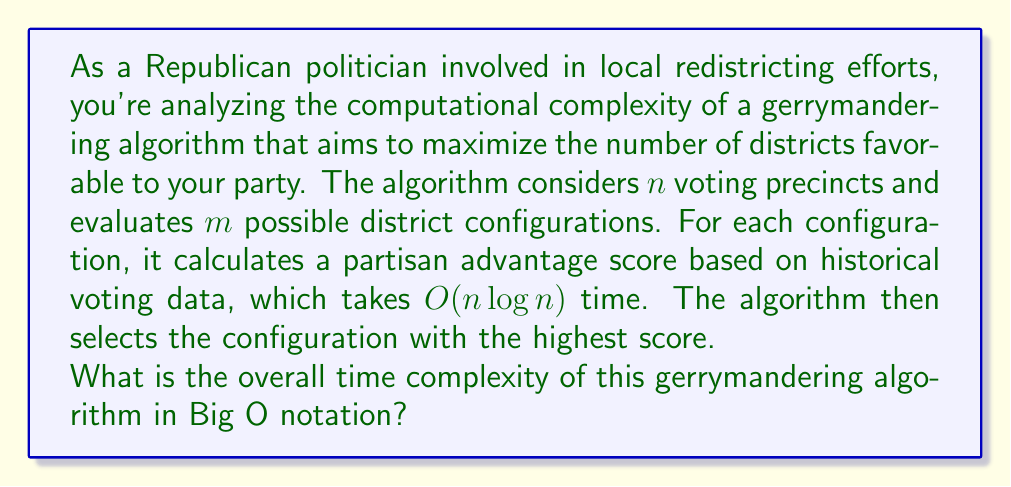Help me with this question. To determine the overall time complexity of the gerrymandering algorithm, we need to analyze its components:

1. The algorithm considers $m$ possible district configurations.

2. For each configuration, it calculates a partisan advantage score, which takes $O(n \log n)$ time, where $n$ is the number of voting precincts.

3. This calculation is performed for each of the $m$ configurations.

4. After calculating all scores, the algorithm selects the configuration with the highest score, which takes $O(m)$ time in the worst case (linear search through all configurations).

The dominant operation is the score calculation, which is performed $m$ times. Therefore, the total time complexity is:

$$ O(m \cdot n \log n + m) $$

Since the $m$ term is dominated by $m \cdot n \log n$ (assuming $n > 1$), we can simplify this to:

$$ O(m \cdot n \log n) $$

This represents the worst-case time complexity of the algorithm, where $m$ is the number of configurations evaluated and $n$ is the number of voting precincts.
Answer: $O(m \cdot n \log n)$ 